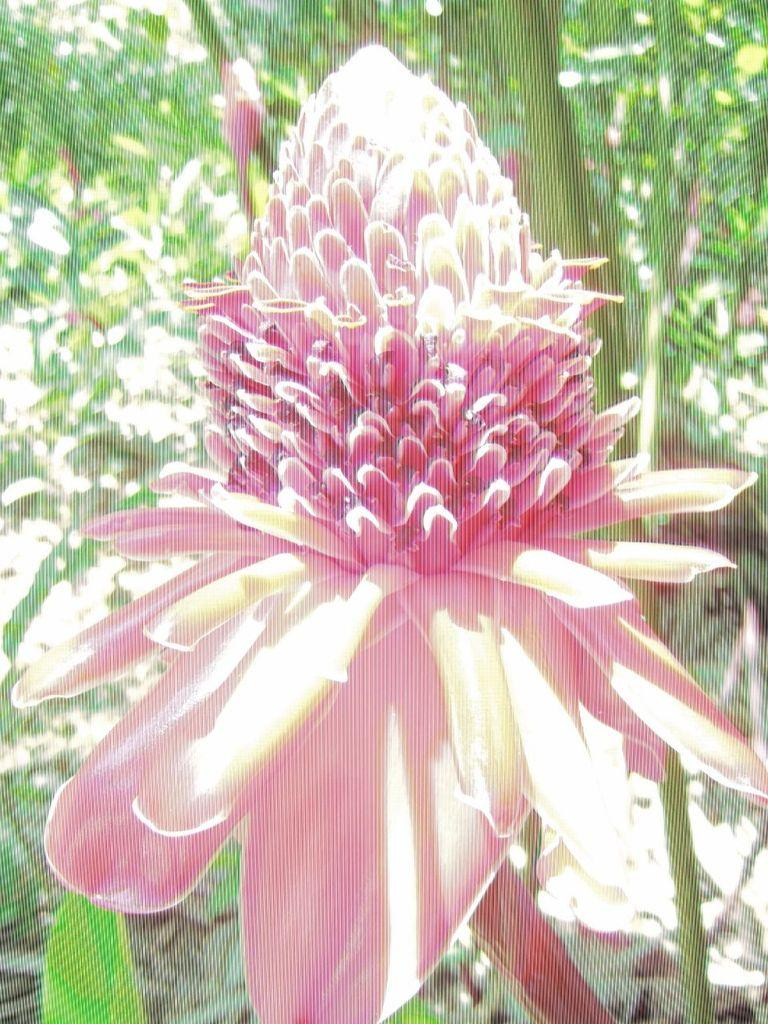What is the main subject in the middle of the picture? There is a pink flower in the middle of the picture. What can be seen in the background of the picture? There are trees in the background of the picture. How many horses are visible in the picture? There are no horses present in the picture; it features a pink flower and trees in the background. What time of day is it in the picture, given the presence of the morning? The provided facts do not mention the time of day or the presence of morning, so it cannot be determined from the image. 